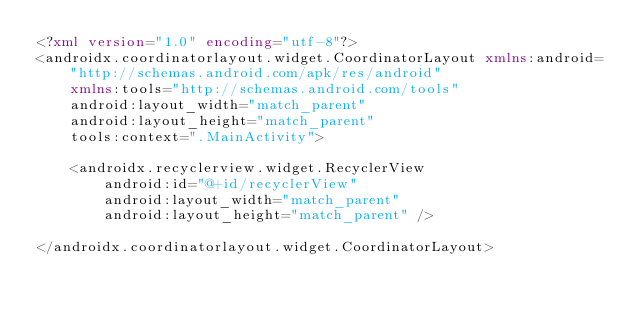<code> <loc_0><loc_0><loc_500><loc_500><_XML_><?xml version="1.0" encoding="utf-8"?>
<androidx.coordinatorlayout.widget.CoordinatorLayout xmlns:android="http://schemas.android.com/apk/res/android"
    xmlns:tools="http://schemas.android.com/tools"
    android:layout_width="match_parent"
    android:layout_height="match_parent"
    tools:context=".MainActivity">

    <androidx.recyclerview.widget.RecyclerView
        android:id="@+id/recyclerView"
        android:layout_width="match_parent"
        android:layout_height="match_parent" />

</androidx.coordinatorlayout.widget.CoordinatorLayout></code> 